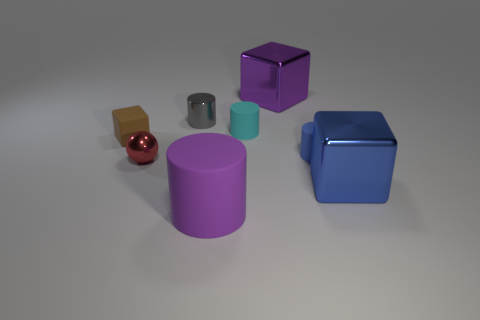Add 1 tiny gray rubber balls. How many objects exist? 9 Subtract all blocks. How many objects are left? 5 Subtract 1 blue cylinders. How many objects are left? 7 Subtract all large blue metallic cylinders. Subtract all brown matte objects. How many objects are left? 7 Add 6 large things. How many large things are left? 9 Add 7 big blue things. How many big blue things exist? 8 